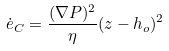Convert formula to latex. <formula><loc_0><loc_0><loc_500><loc_500>\dot { e } _ { C } = \frac { ( \nabla P ) ^ { 2 } } { \eta } ( z - h _ { o } ) ^ { 2 }</formula> 